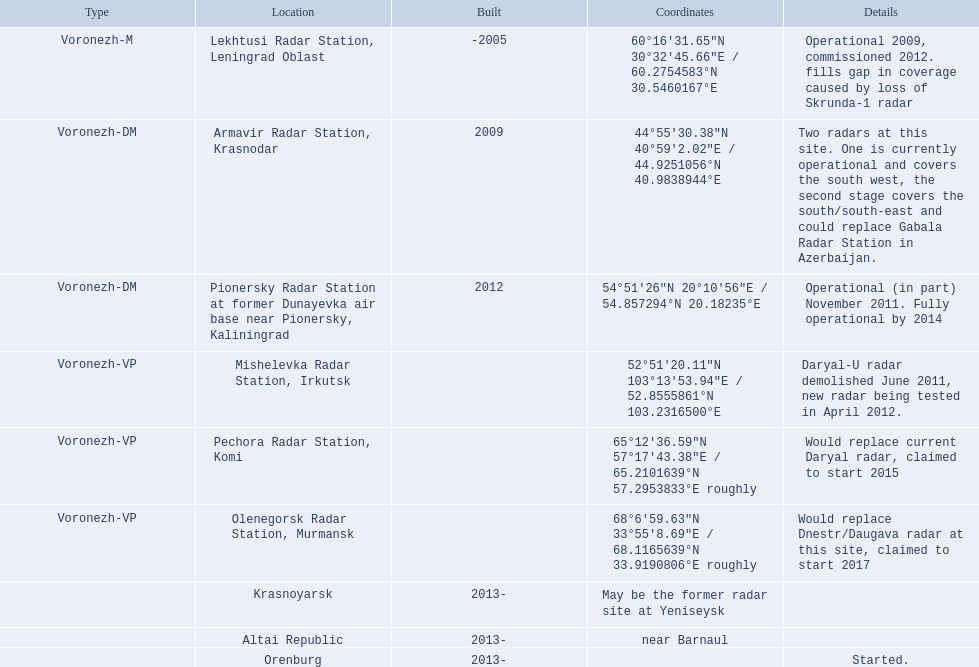What are the list of radar locations? Lekhtusi Radar Station, Leningrad Oblast, Armavir Radar Station, Krasnodar, Pionersky Radar Station at former Dunayevka air base near Pionersky, Kaliningrad, Mishelevka Radar Station, Irkutsk, Pechora Radar Station, Komi, Olenegorsk Radar Station, Murmansk, Krasnoyarsk, Altai Republic, Orenburg. Which of these are claimed to start in 2015? Pechora Radar Station, Komi. 